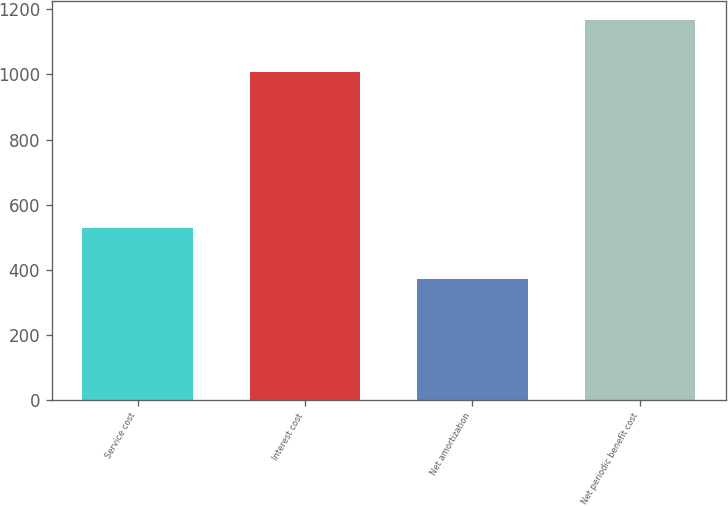<chart> <loc_0><loc_0><loc_500><loc_500><bar_chart><fcel>Service cost<fcel>Interest cost<fcel>Net amortization<fcel>Net periodic benefit cost<nl><fcel>528<fcel>1008<fcel>370<fcel>1166<nl></chart> 